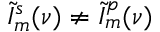<formula> <loc_0><loc_0><loc_500><loc_500>\tilde { I } _ { m } ^ { s } ( \nu ) \neq \tilde { I } _ { m } ^ { p } ( \nu )</formula> 